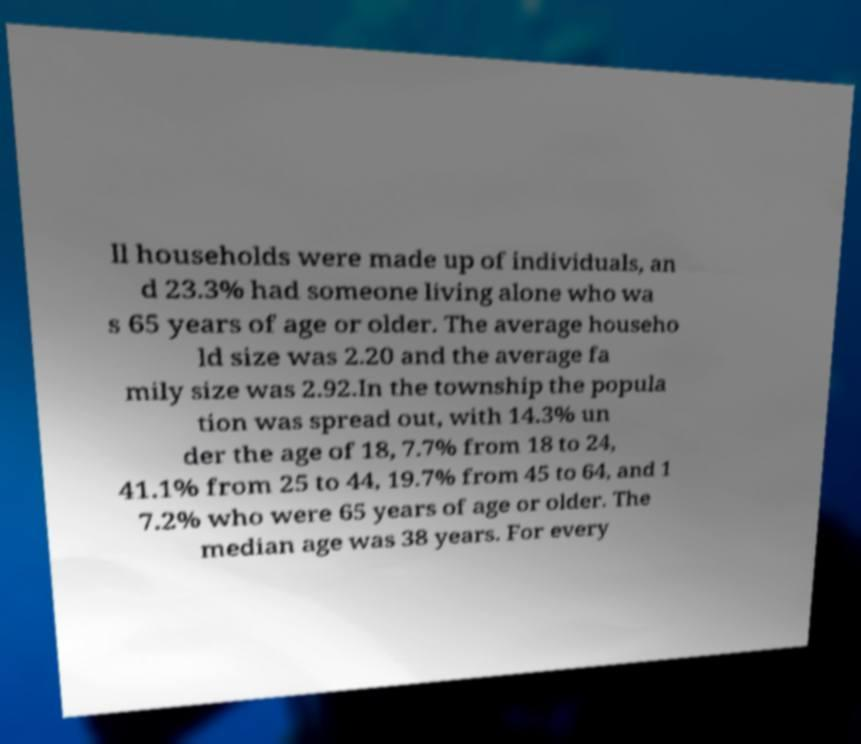Could you assist in decoding the text presented in this image and type it out clearly? ll households were made up of individuals, an d 23.3% had someone living alone who wa s 65 years of age or older. The average househo ld size was 2.20 and the average fa mily size was 2.92.In the township the popula tion was spread out, with 14.3% un der the age of 18, 7.7% from 18 to 24, 41.1% from 25 to 44, 19.7% from 45 to 64, and 1 7.2% who were 65 years of age or older. The median age was 38 years. For every 